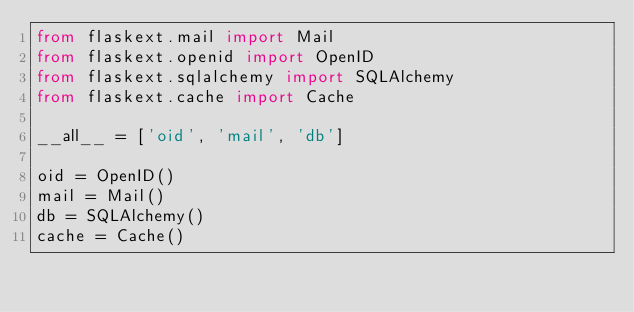Convert code to text. <code><loc_0><loc_0><loc_500><loc_500><_Python_>from flaskext.mail import Mail
from flaskext.openid import OpenID
from flaskext.sqlalchemy import SQLAlchemy
from flaskext.cache import Cache

__all__ = ['oid', 'mail', 'db']

oid = OpenID()
mail = Mail()
db = SQLAlchemy()
cache = Cache()

</code> 